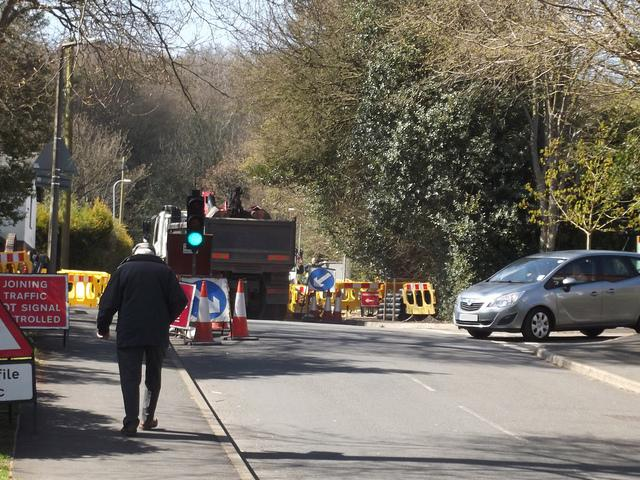What is the possible danger that will occur in the scene?

Choices:
A) tree falling
B) construction collapsed
C) wrong signal
D) pedestrian hit wrong signal 